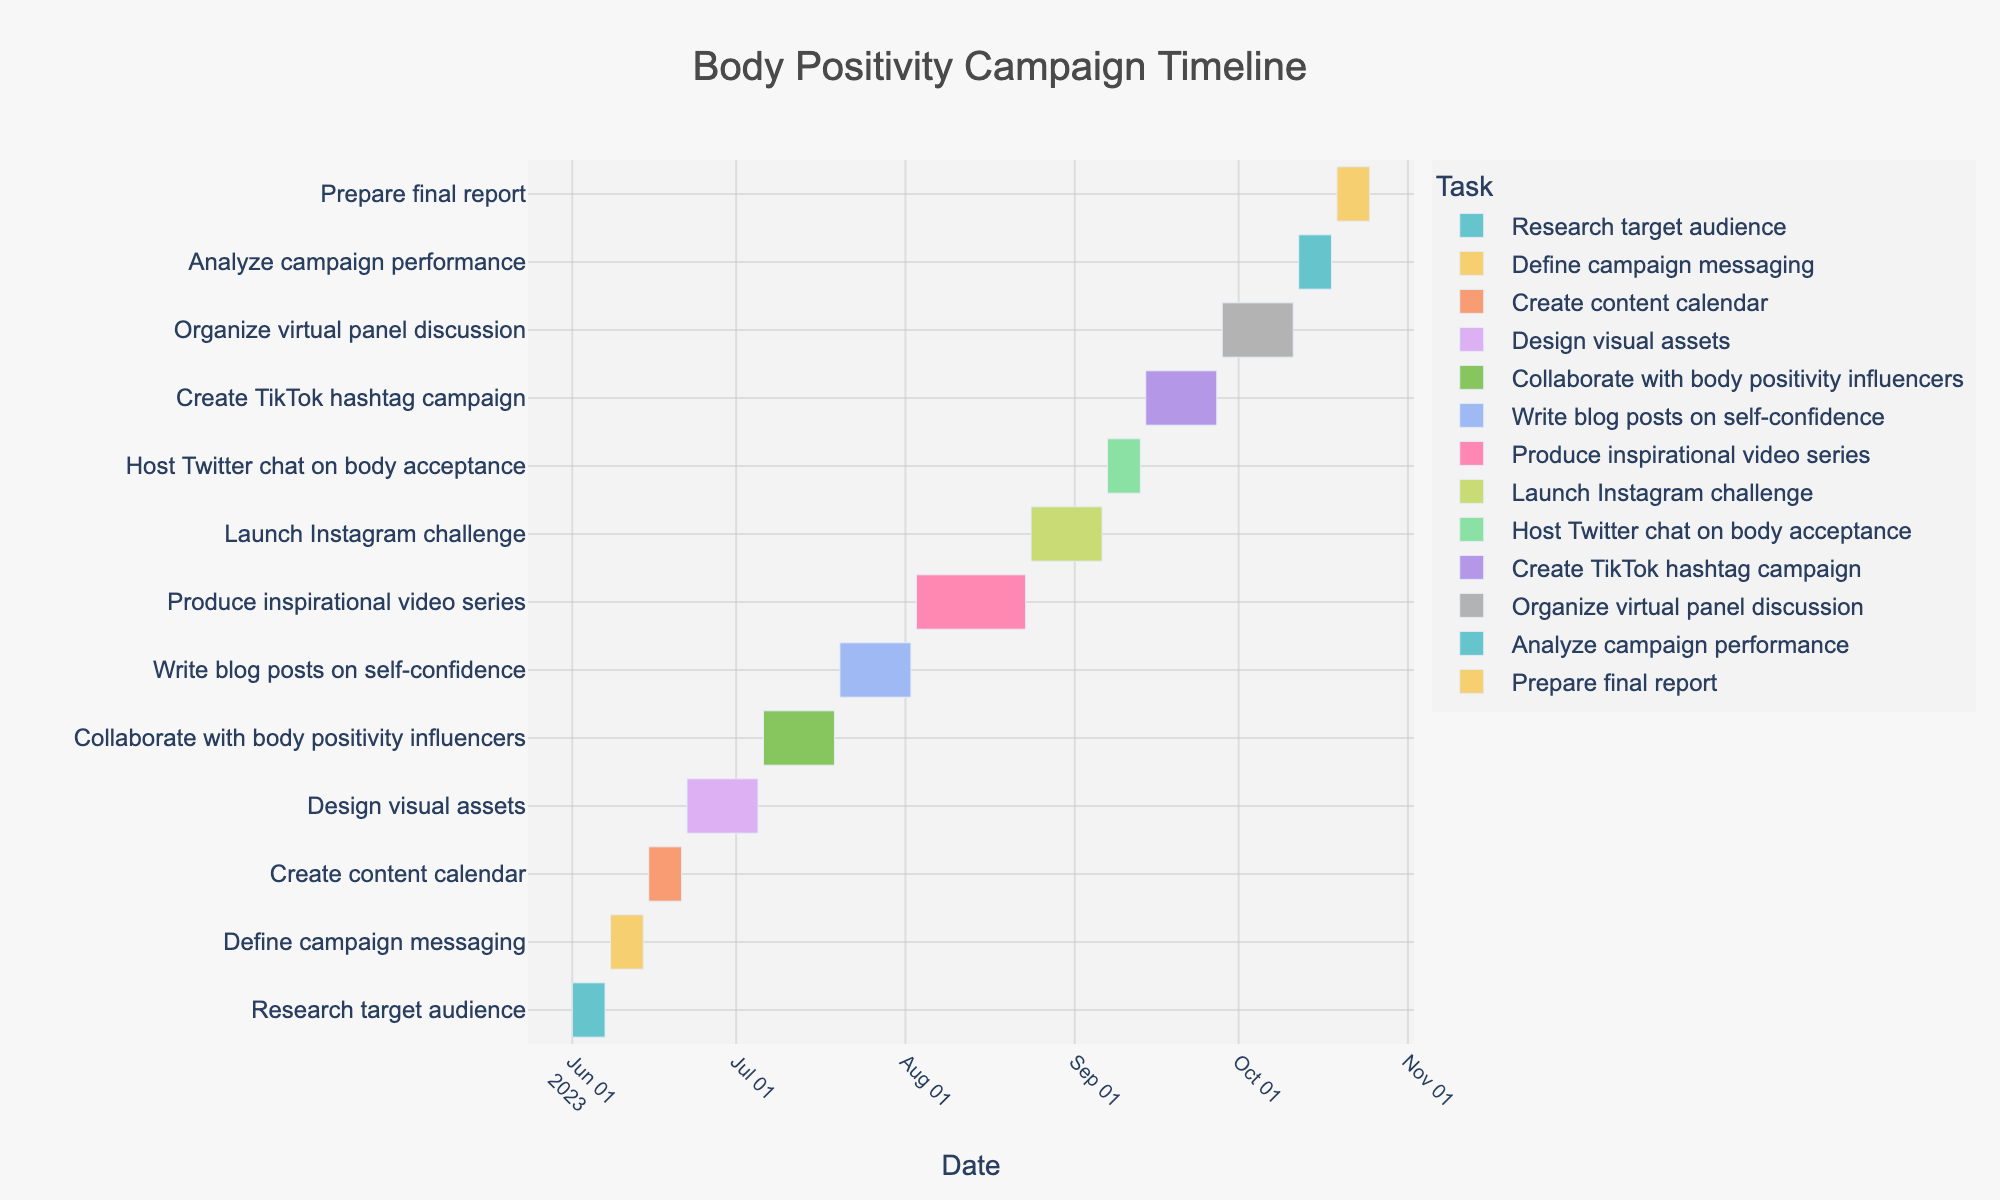what is the title of the Gantt chart? The title can be found at the top of the figure. It provides a summary of the visualized data, giving viewers context. In this case, it is specified in the code as "Body Positivity Campaign Timeline".
Answer: Body Positivity Campaign Timeline When does the design visual assets task start and end? The dates for each task are displayed as horizontal bars on the Gantt chart. For the "Design visual assets" task, it starts on 2023-06-22 and ends on 2023-07-05.
Answer: 2023-06-22 to 2023-07-05 How long does the "Produce inspirational video series" task take? The duration of each task is indicated by the length of the corresponding bar, and the details can be seen in the hover information. For the "Produce inspirational video series" task, it spans from 2023-08-03 to 2023-08-23, which is 21 days.
Answer: 21 days Which task is scheduled to end the latest? By examining the end dates of all tasks, we see that the task scheduled to end the latest is "Prepare final report". It ends on 2023-10-25, which is the latest date on the chart.
Answer: Prepare final report What is the total duration from the start of the first task to the end of the last task? The total duration can be calculated as the difference between the start date of the first task and the end date of the last task. The first task starts on 2023-06-01 and the last task ends on 2023-10-25, so the total duration is from June 1 to October 25. This is 147 days.
Answer: 147 days What tasks overlap with the "Collaborate with body positivity influencers" task? To find overlapping tasks, look at other tasks that share any dates within the 2023-07-06 to 2023-07-19 range. The overlapping task is "Design visual assets" which ends on 2023-07-05.
Answer: Design visual assets Which tasks take longer than two weeks to complete? Tasks longer than two weeks have bars that span more than 14 days. "Design visual assets" (14 days) and "Produce inspirational video series" (21 days) meet this criterion.
Answer: Design visual assets, Produce inspirational video series How many tasks are planned for August? Check for tasks with start or end dates within August. The tasks are "Produce inspirational video series" (2023-08-03 to 2023-08-23) and "Launch Instagram challenge" (2023-08-24 to 2023-09-06).
Answer: 2 tasks Which task directly follows "Write blog posts on self-confidence"? The task that starts immediately after "Write blog posts on self-confidence", which ends on 2023-08-02, is "Produce inspirational video series" starting on 2023-08-03.
Answer: Produce inspirational video series What is the shortest task in the timeline and its duration? By comparing the bar lengths, the shortest task is "Analyze campaign performance", which spans from 2023-10-12 to 2023-10-18, lasting 7 days.
Answer: Analyze campaign performance, 7 days 